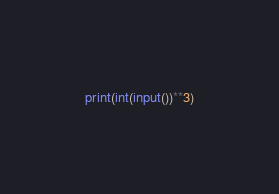<code> <loc_0><loc_0><loc_500><loc_500><_Python_>print(int(input())**3)</code> 